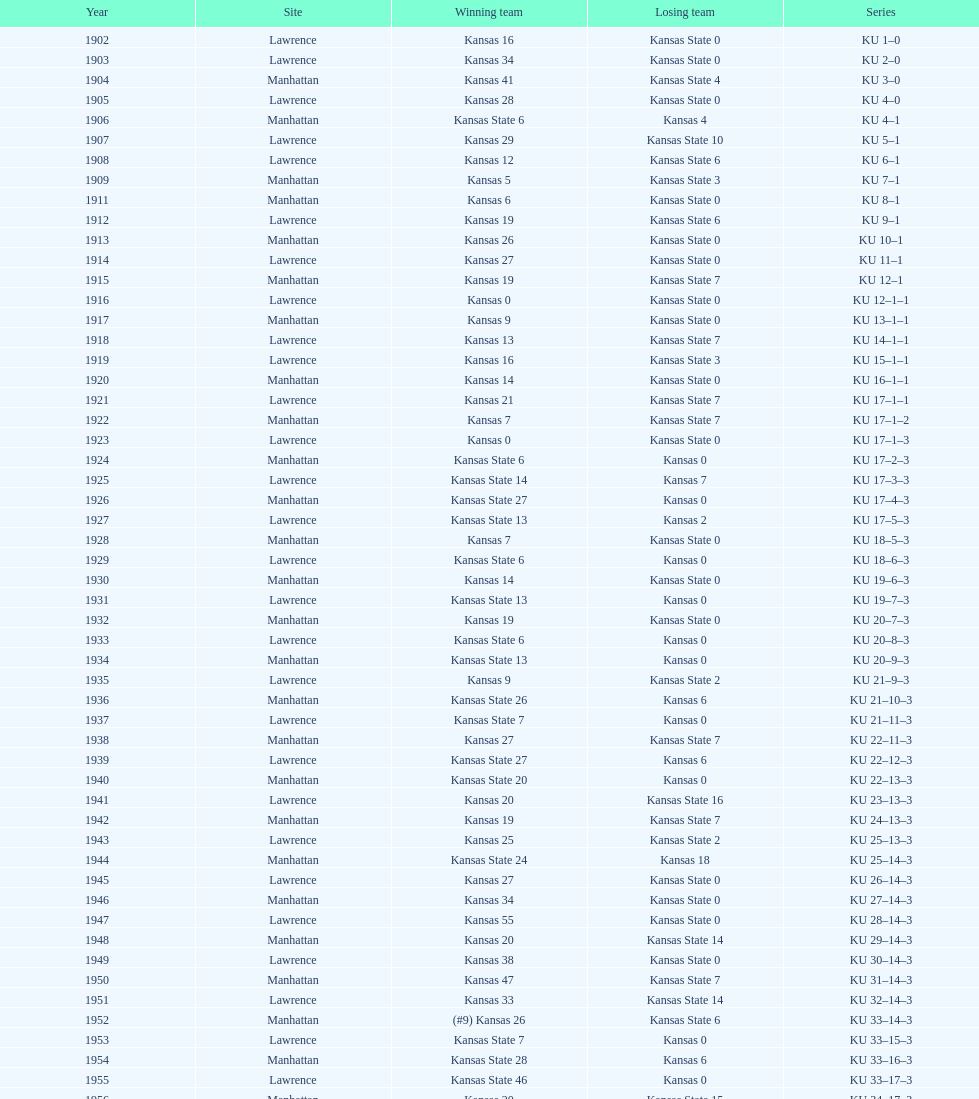How many wins did kansas secure against kansas state before the year 1910? 7. 